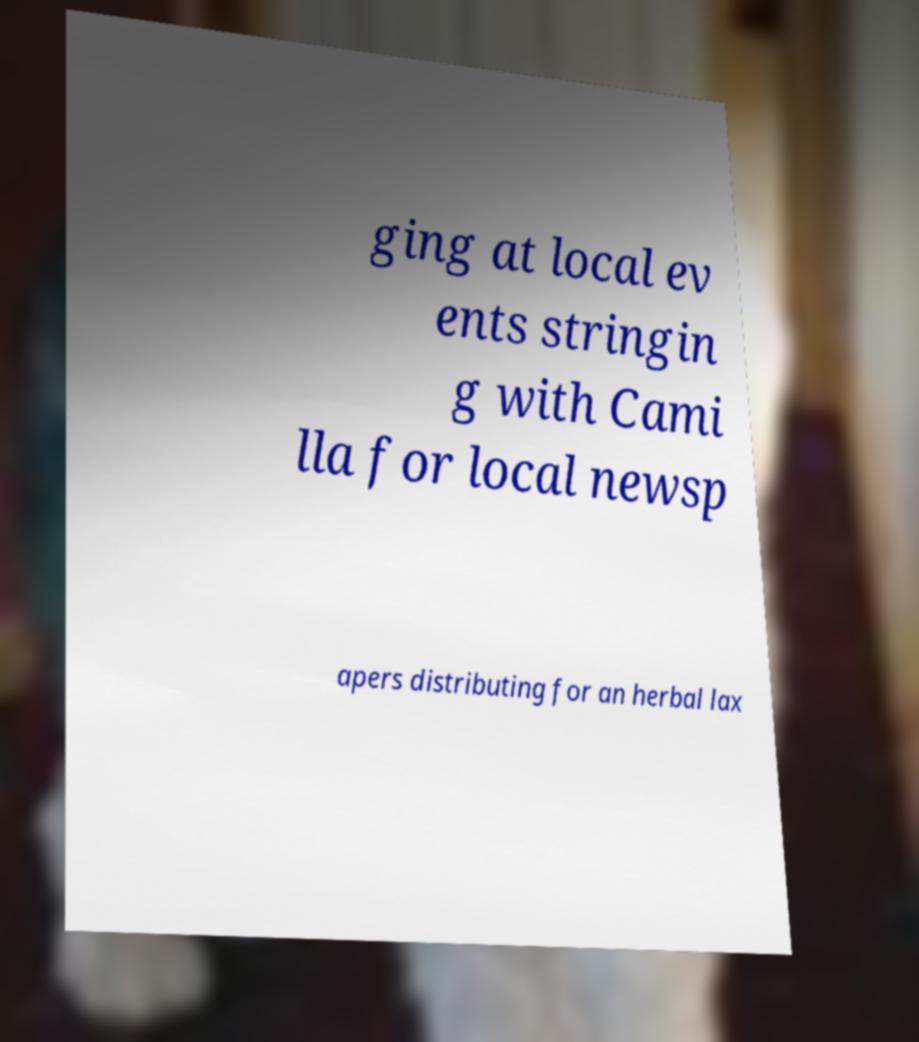Could you assist in decoding the text presented in this image and type it out clearly? ging at local ev ents stringin g with Cami lla for local newsp apers distributing for an herbal lax 